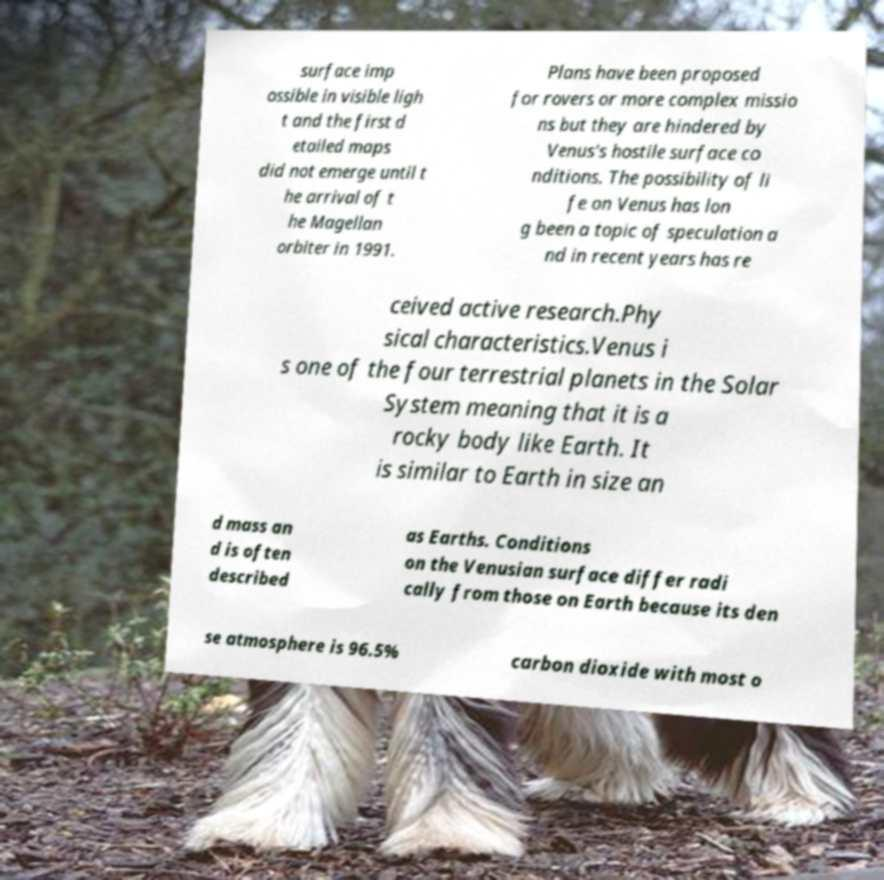Please identify and transcribe the text found in this image. surface imp ossible in visible ligh t and the first d etailed maps did not emerge until t he arrival of t he Magellan orbiter in 1991. Plans have been proposed for rovers or more complex missio ns but they are hindered by Venus's hostile surface co nditions. The possibility of li fe on Venus has lon g been a topic of speculation a nd in recent years has re ceived active research.Phy sical characteristics.Venus i s one of the four terrestrial planets in the Solar System meaning that it is a rocky body like Earth. It is similar to Earth in size an d mass an d is often described as Earths. Conditions on the Venusian surface differ radi cally from those on Earth because its den se atmosphere is 96.5% carbon dioxide with most o 